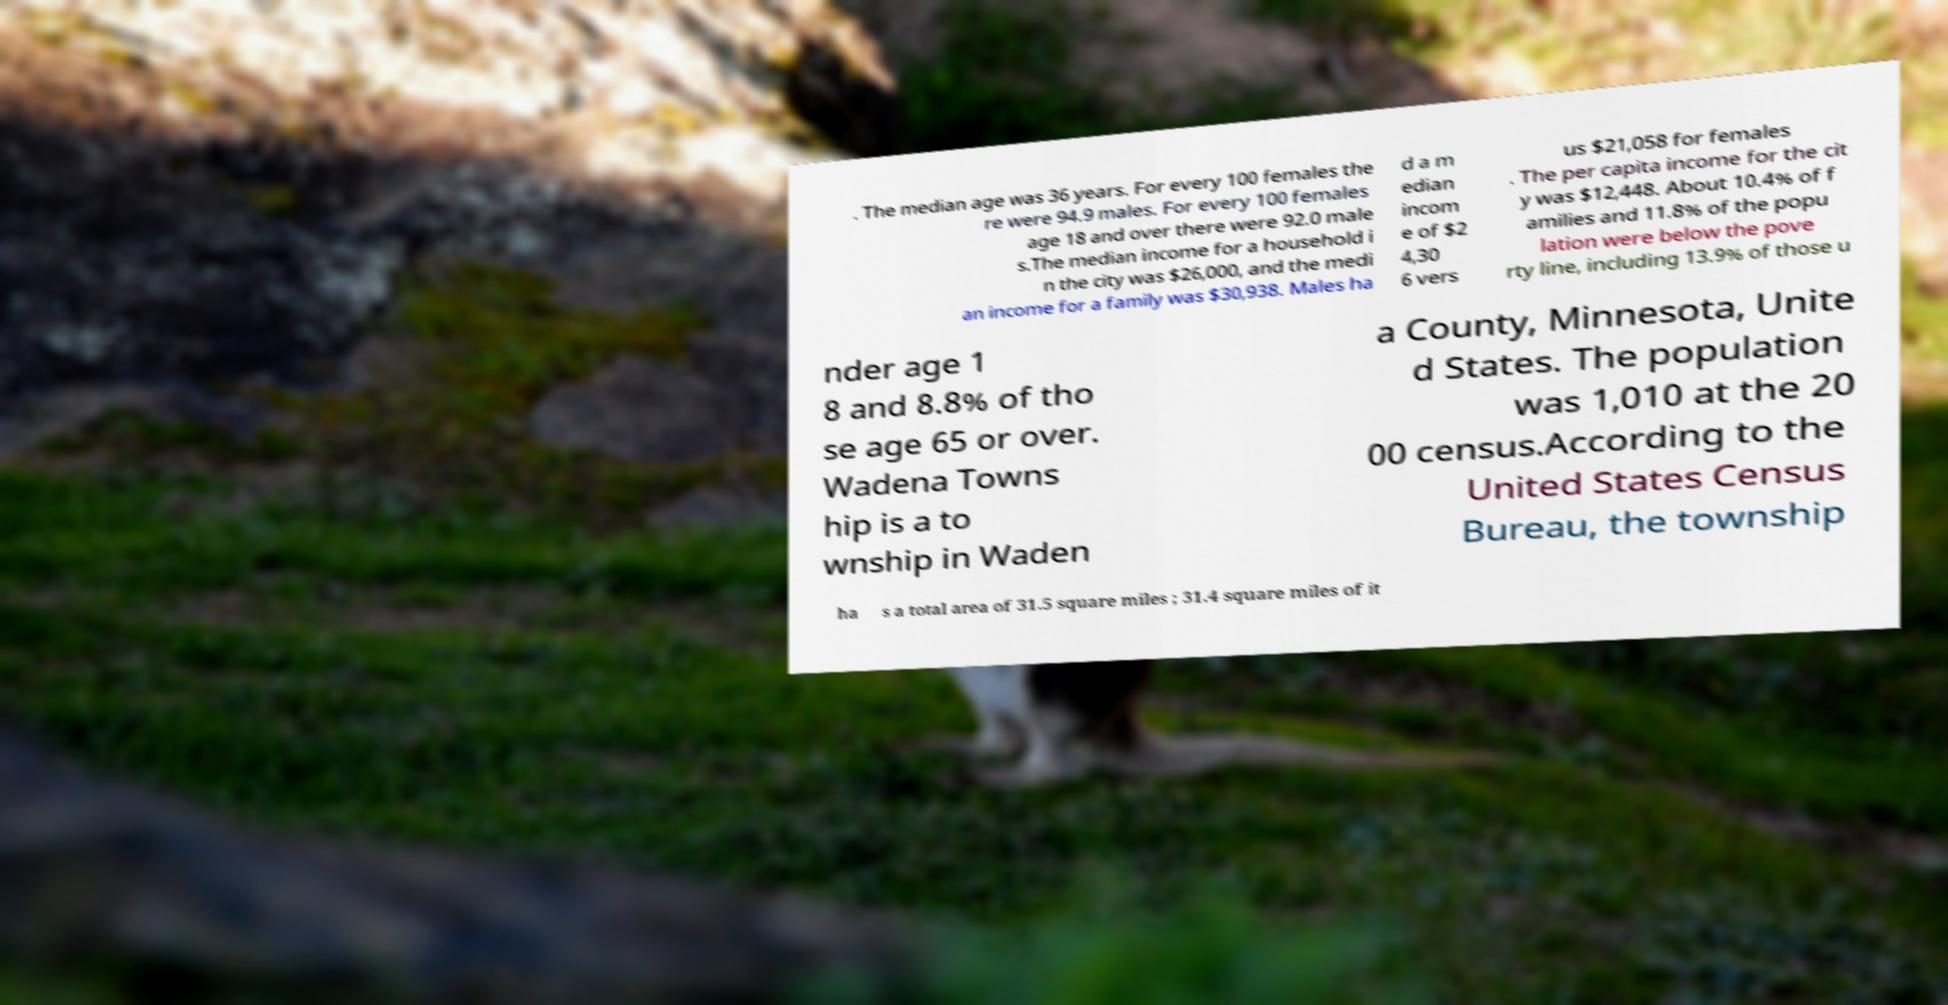Please read and relay the text visible in this image. What does it say? . The median age was 36 years. For every 100 females the re were 94.9 males. For every 100 females age 18 and over there were 92.0 male s.The median income for a household i n the city was $26,000, and the medi an income for a family was $30,938. Males ha d a m edian incom e of $2 4,30 6 vers us $21,058 for females . The per capita income for the cit y was $12,448. About 10.4% of f amilies and 11.8% of the popu lation were below the pove rty line, including 13.9% of those u nder age 1 8 and 8.8% of tho se age 65 or over. Wadena Towns hip is a to wnship in Waden a County, Minnesota, Unite d States. The population was 1,010 at the 20 00 census.According to the United States Census Bureau, the township ha s a total area of 31.5 square miles ; 31.4 square miles of it 